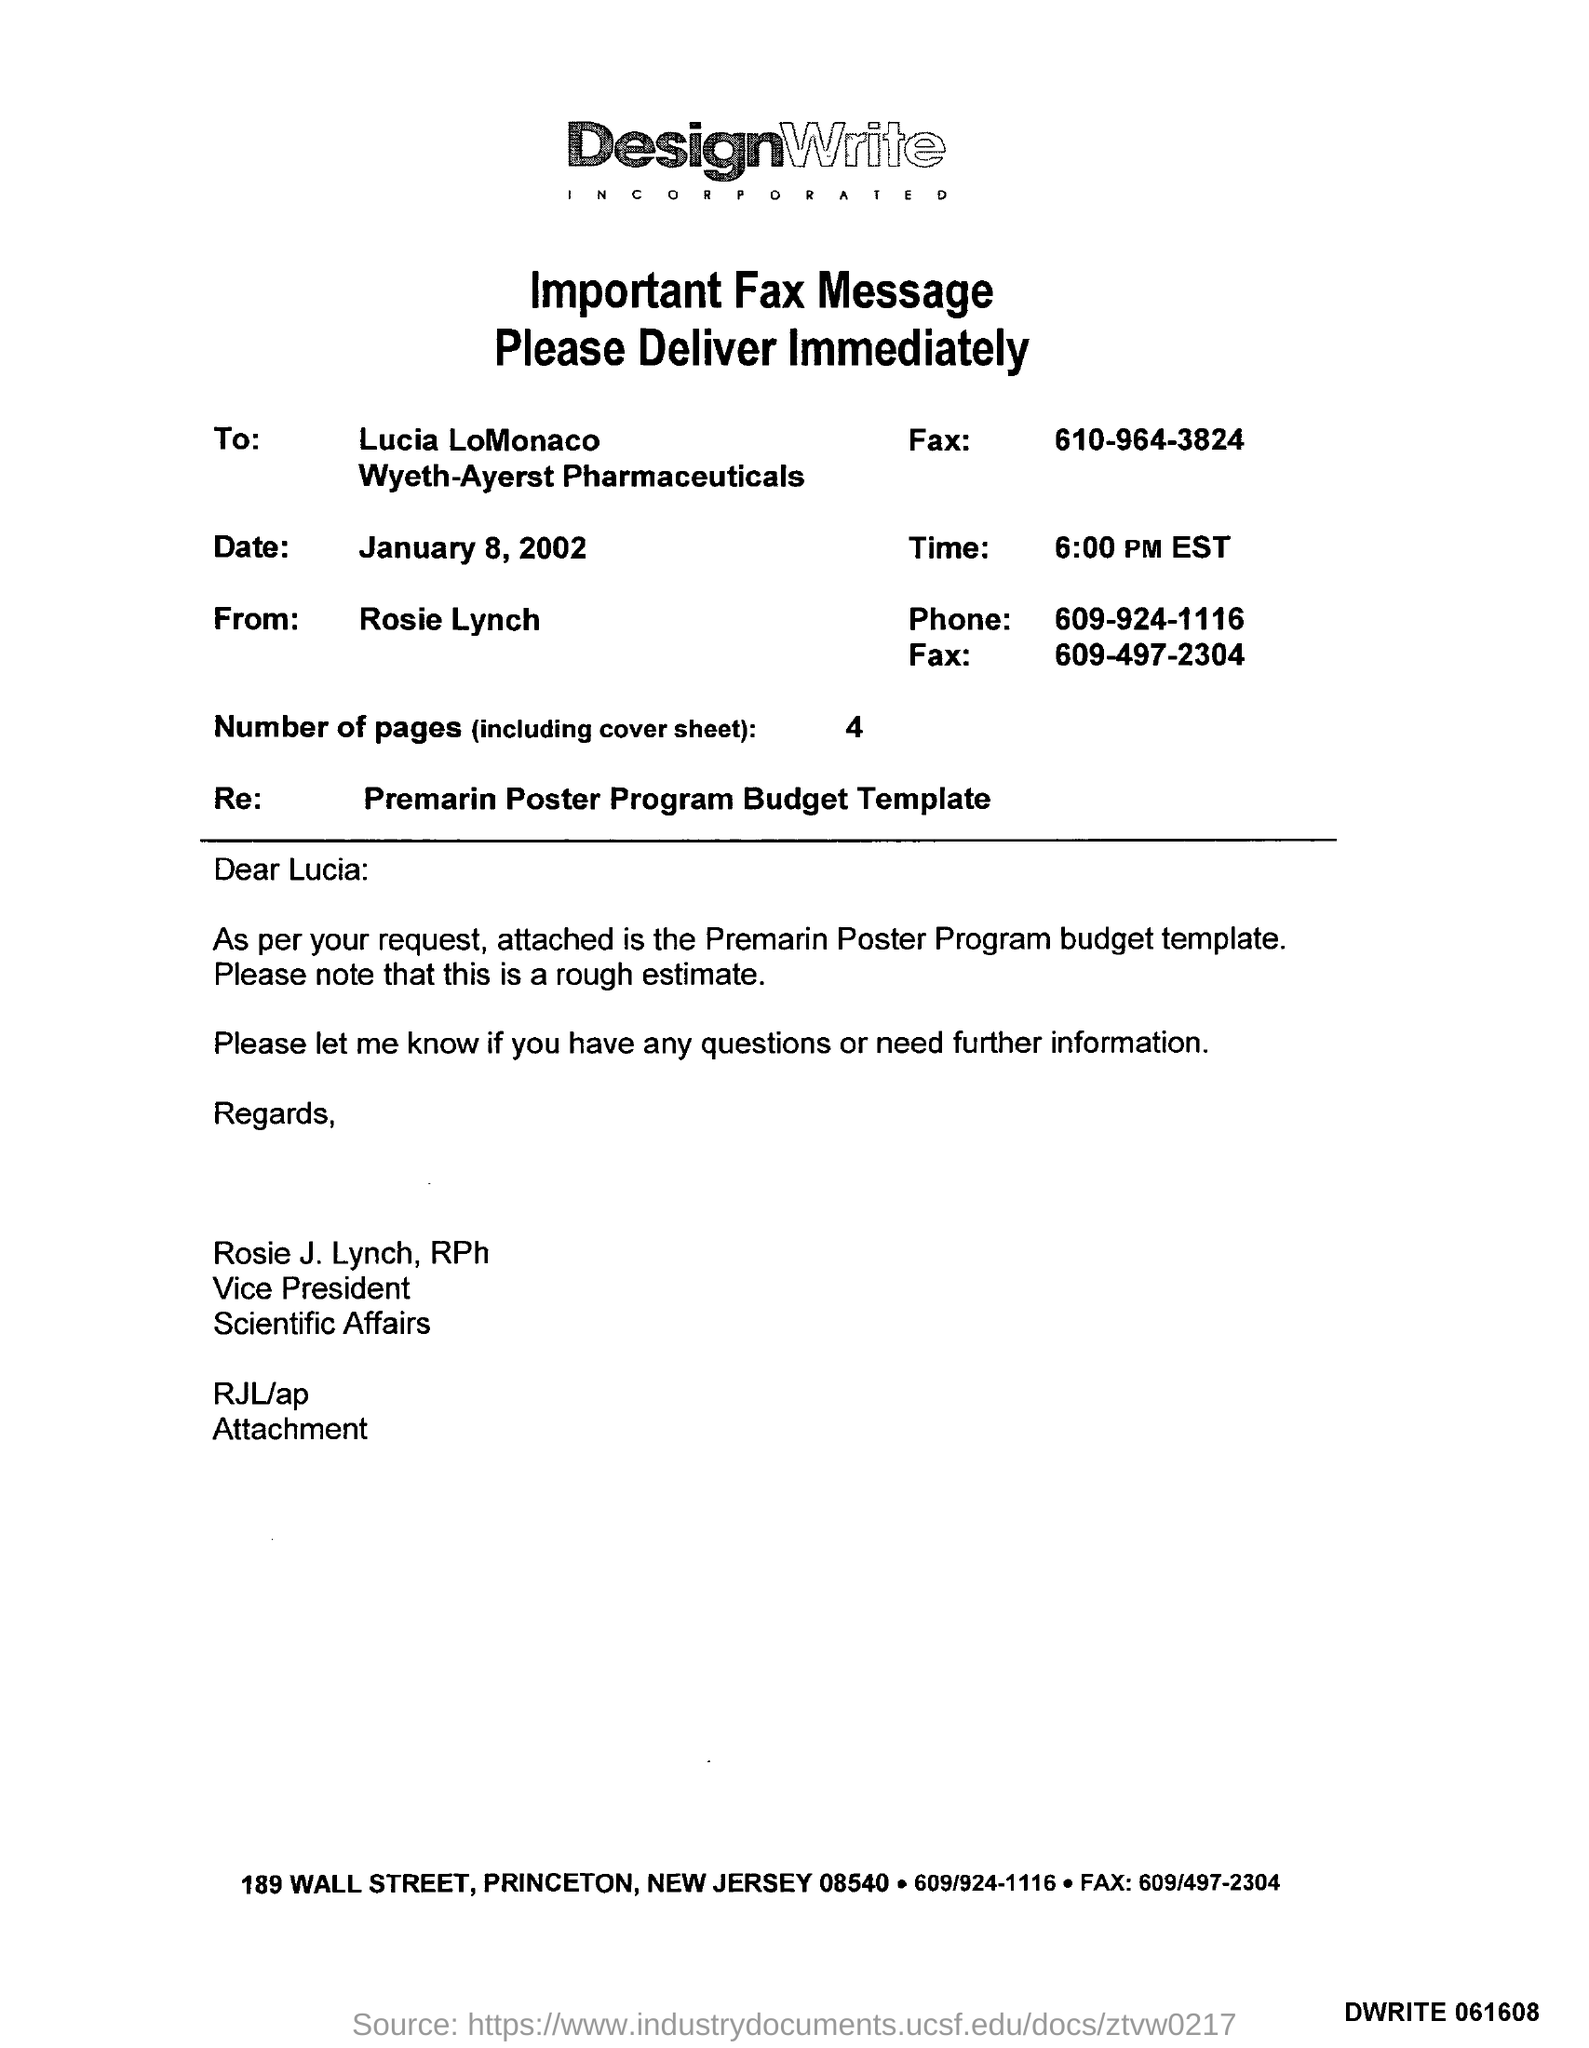Give some essential details in this illustration. The phone number mentioned in the fax message is 609-924-1116. The "RE" mentioned in the given fax message is "Regular Estimate." The text of the message is: "What is the RE mentioned in the given fax message? Premarin poster program budget template.. There are a total of four pages, including the cover sheet. The recipient of the fax message was Lucia LoMonaco. The date mentioned in the fax message is January 8, 2002. 